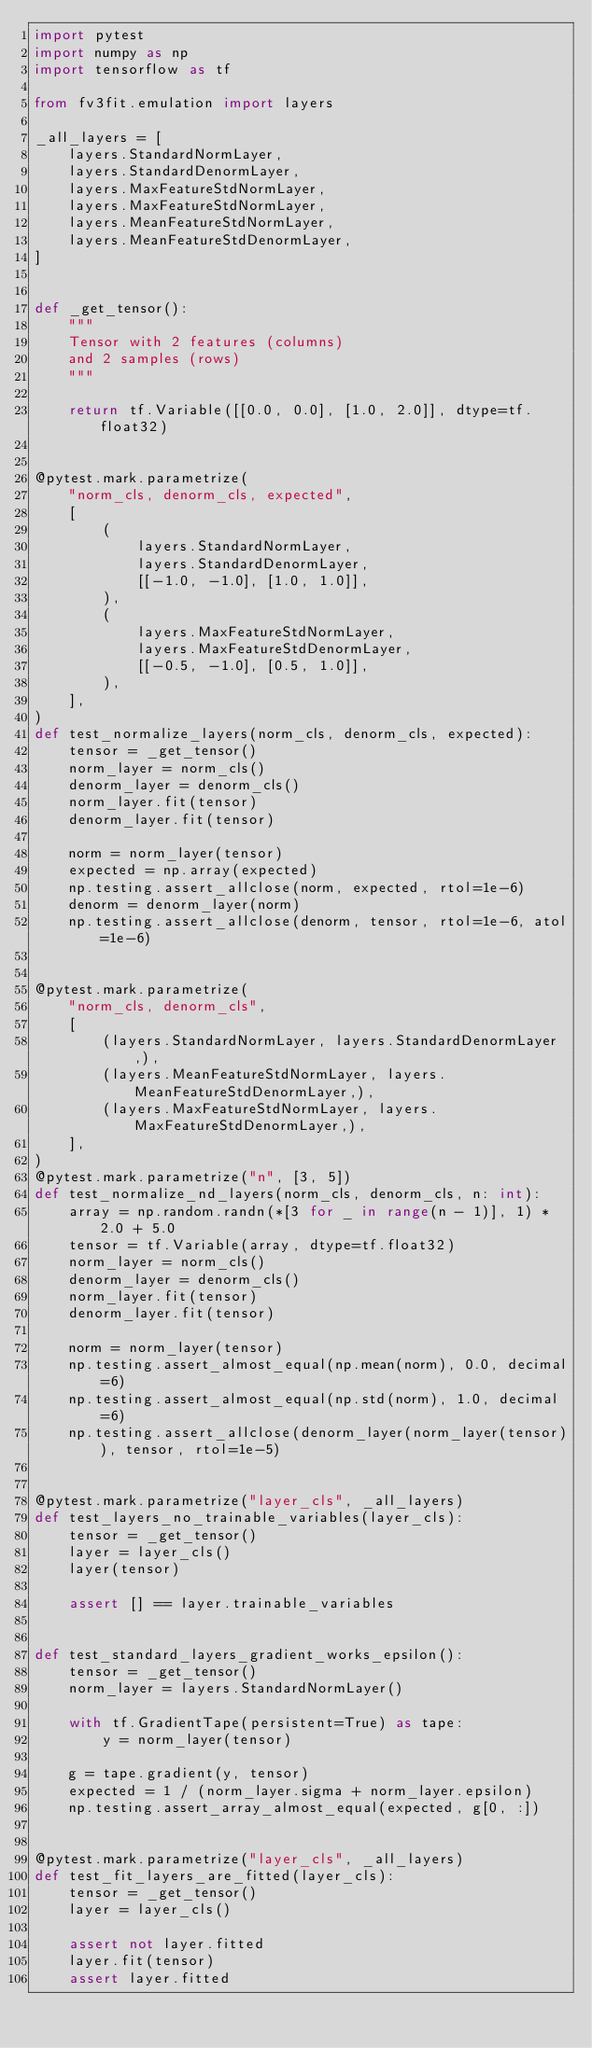Convert code to text. <code><loc_0><loc_0><loc_500><loc_500><_Python_>import pytest
import numpy as np
import tensorflow as tf

from fv3fit.emulation import layers

_all_layers = [
    layers.StandardNormLayer,
    layers.StandardDenormLayer,
    layers.MaxFeatureStdNormLayer,
    layers.MaxFeatureStdNormLayer,
    layers.MeanFeatureStdNormLayer,
    layers.MeanFeatureStdDenormLayer,
]


def _get_tensor():
    """
    Tensor with 2 features (columns)
    and 2 samples (rows)
    """

    return tf.Variable([[0.0, 0.0], [1.0, 2.0]], dtype=tf.float32)


@pytest.mark.parametrize(
    "norm_cls, denorm_cls, expected",
    [
        (
            layers.StandardNormLayer,
            layers.StandardDenormLayer,
            [[-1.0, -1.0], [1.0, 1.0]],
        ),
        (
            layers.MaxFeatureStdNormLayer,
            layers.MaxFeatureStdDenormLayer,
            [[-0.5, -1.0], [0.5, 1.0]],
        ),
    ],
)
def test_normalize_layers(norm_cls, denorm_cls, expected):
    tensor = _get_tensor()
    norm_layer = norm_cls()
    denorm_layer = denorm_cls()
    norm_layer.fit(tensor)
    denorm_layer.fit(tensor)

    norm = norm_layer(tensor)
    expected = np.array(expected)
    np.testing.assert_allclose(norm, expected, rtol=1e-6)
    denorm = denorm_layer(norm)
    np.testing.assert_allclose(denorm, tensor, rtol=1e-6, atol=1e-6)


@pytest.mark.parametrize(
    "norm_cls, denorm_cls",
    [
        (layers.StandardNormLayer, layers.StandardDenormLayer,),
        (layers.MeanFeatureStdNormLayer, layers.MeanFeatureStdDenormLayer,),
        (layers.MaxFeatureStdNormLayer, layers.MaxFeatureStdDenormLayer,),
    ],
)
@pytest.mark.parametrize("n", [3, 5])
def test_normalize_nd_layers(norm_cls, denorm_cls, n: int):
    array = np.random.randn(*[3 for _ in range(n - 1)], 1) * 2.0 + 5.0
    tensor = tf.Variable(array, dtype=tf.float32)
    norm_layer = norm_cls()
    denorm_layer = denorm_cls()
    norm_layer.fit(tensor)
    denorm_layer.fit(tensor)

    norm = norm_layer(tensor)
    np.testing.assert_almost_equal(np.mean(norm), 0.0, decimal=6)
    np.testing.assert_almost_equal(np.std(norm), 1.0, decimal=6)
    np.testing.assert_allclose(denorm_layer(norm_layer(tensor)), tensor, rtol=1e-5)


@pytest.mark.parametrize("layer_cls", _all_layers)
def test_layers_no_trainable_variables(layer_cls):
    tensor = _get_tensor()
    layer = layer_cls()
    layer(tensor)

    assert [] == layer.trainable_variables


def test_standard_layers_gradient_works_epsilon():
    tensor = _get_tensor()
    norm_layer = layers.StandardNormLayer()

    with tf.GradientTape(persistent=True) as tape:
        y = norm_layer(tensor)

    g = tape.gradient(y, tensor)
    expected = 1 / (norm_layer.sigma + norm_layer.epsilon)
    np.testing.assert_array_almost_equal(expected, g[0, :])


@pytest.mark.parametrize("layer_cls", _all_layers)
def test_fit_layers_are_fitted(layer_cls):
    tensor = _get_tensor()
    layer = layer_cls()

    assert not layer.fitted
    layer.fit(tensor)
    assert layer.fitted
</code> 